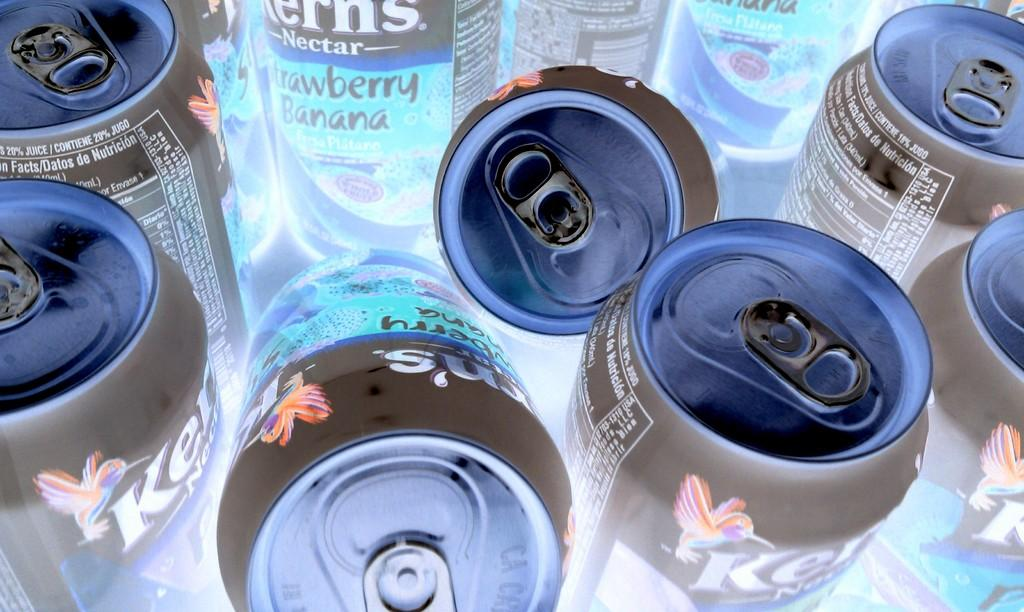What objects are present in the image? There are tins in the image. Can you describe the appearance of the tins? The provided facts do not include a description of the tins' appearance. Are there any other objects or elements visible in the image? The provided facts do not mention any other objects or elements in the image. What type of stick is being used to rest on the tins in the image? There is no stick or any other object resting on the tins in the image. 